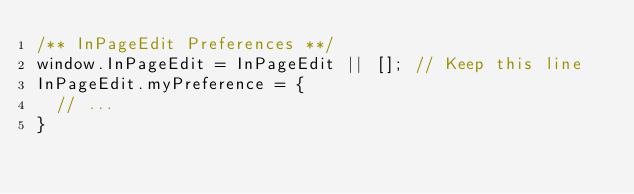<code> <loc_0><loc_0><loc_500><loc_500><_JavaScript_>/** InPageEdit Preferences **/
window.InPageEdit = InPageEdit || []; // Keep this line
InPageEdit.myPreference = {
  // ...
}</code> 